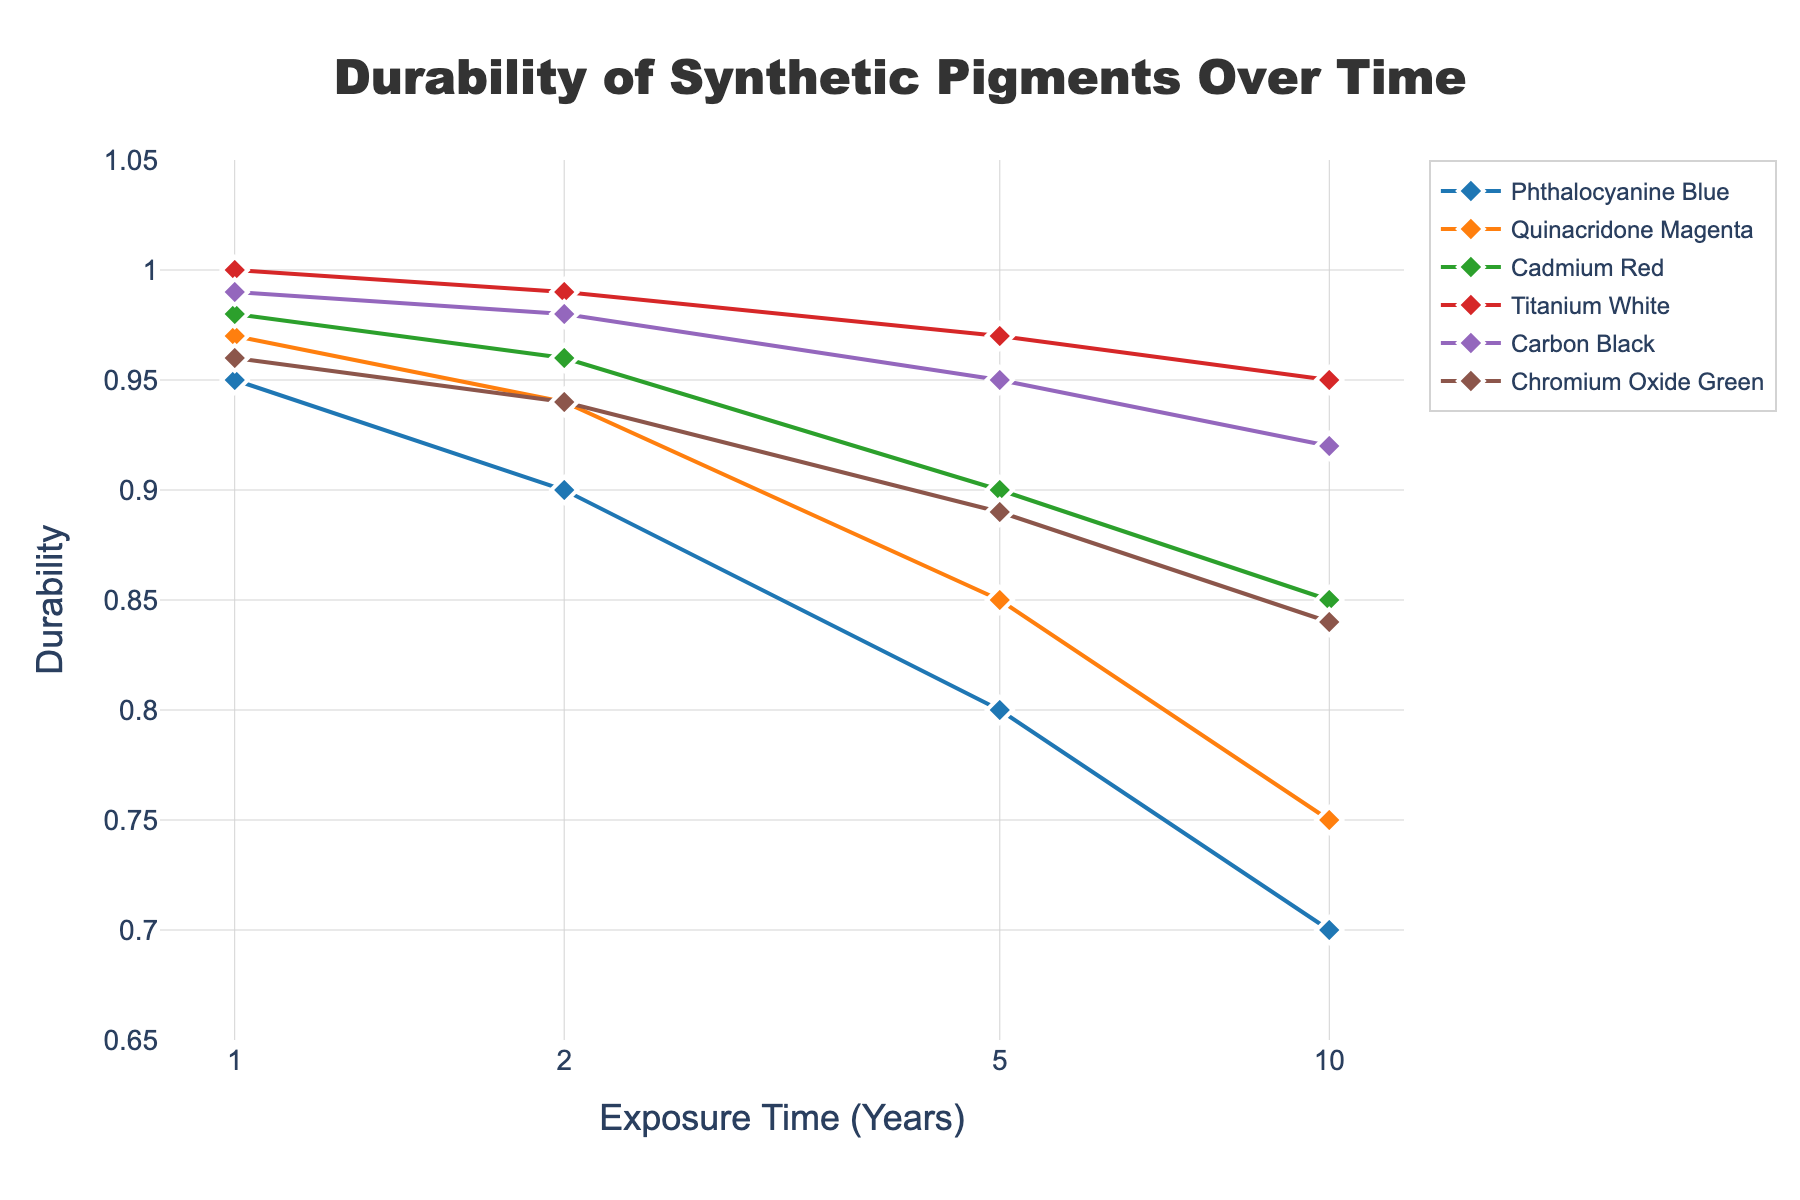What is the title of the scatter plot? The title of the scatter plot is located at the top of the figure and is centered. It describes the overall content and purpose of the plot.
Answer: Durability of Synthetic Pigments Over Time What is the y-axis title? The y-axis title is present vertically along the left side of the figure, indicating what is being measured on that axis.
Answer: Durability How many data points does Phthalocyanine Blue have? To determine the number of data points for Phthalocyanine Blue, count the markers in the scatter plot series labeled for this pigment. Each marker represents one data point.
Answer: 4 Which pigment has the highest durability after 10 years of exposure? Examine the y-axis values for the 10-year exposure data points. Identify which pigment's data point is highest along the y-axis.
Answer: Cadmium Red What is the durability of Titanium White after 5 years of exposure? Locate the data point on the Titanium White series that corresponds to 5 years on the x-axis and read its y-axis value.
Answer: 0.97 How does the durability of Carbon Black compare to Quinacridone Magenta after 2 years of exposure? Identify the data points for Carbon Black and Quinacridone Magenta at 2 years on the x-axis, then compare their y-axis values.
Answer: Carbon Black has higher durability (0.98 vs. 0.94) Among the pigments, which one shows the least reduction in durability over 10 years? Calculate the difference in durability from 1 to 10 years for each pigment, then identify which has the smallest reduction by subtracting the 10-year value from the 1-year value for each.
Answer: Titanium White (0.05 reduction) By how much does the durability of Chromium Oxide Green decrease from 1 year to 5 years of exposure? Subtract the durability value at 5 years from the durability value at 1 year for Chromium Oxide Green.
Answer: 0.07 What pattern can be observed regarding the change in durability over time for Phthalocyanine Blue? Analyze the trend of the durability values for Phthalocyanine Blue as the exposure time increases. Note if the durability consistently decreases and the pattern of this change.
Answer: Durability decreases consistently over time What is the average durability of Cadmium Red over all exposure times shown? Calculate the mean of the durability values for Cadmium Red by summing the values at each exposure time and then dividing by the number of data points.
Answer: (0.98 + 0.96 + 0.90 + 0.85) / 4 = 0.9225 